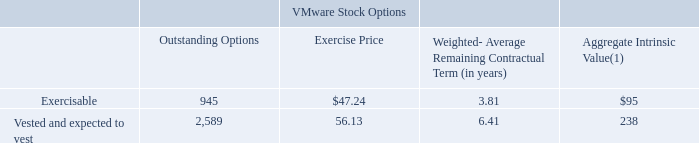Options outstanding that are exercisable and that have vested and are expected to vest as of January 31, 2020 were as follows (outstanding options in thousands, aggregate intrinsic value in in millions):
(1) The aggregate intrinsic values represent the total pre-tax intrinsic values based on VMware's closing stock price of $148.06 as of January 31, 2020, which would have been received by the option holders had all in-the-money options been exercised as of that date.
The total fair value of VMware stock options that vested during the years ended January 31, 2020, February 1, 2019 and February 2, 2018 was $64 million, $35 million and $32 million, respectively. Total fair value of Pivotal stock options that vested during the years ended January 31, 2020, February 1, 2019 and February 2, 2018 was $27 million, $41 million and $23 million, respectively.
The VMware stock options exercised during the years ended January 31, 2020, February 1, 2019 and February 2, 2018 had a pre-tax intrinsic value of $103 million, $56 million, and $62 million, respectively. The Pivotal options exercised during the years ended January 31, 2020 and February 1, 2019 had a pre-tax intrinsic value of $278 million and $97 million, respectively, and was not material during the year ended February 2, 2018. The pre-tax intrinsic value of Pivotal options exercised during the year ended January 31, 2020 includes vested options that were settled in cash as part of the Pivotal acquisition.
What did the aggregate intrinsic value represent? The total pre-tax intrinsic values based on vmware's closing stock price of $148.06 as of january 31, 2020, which would have been received by the option holders had all in-the-money options been exercised as of that date. What was the amount of exercisable outstanding options?
Answer scale should be: thousand. 945. What was the aggregate intrinsic value that was vested and expected to vest?
Answer scale should be: million. 238. What was the difference between outstanding options that were exercisable and vested and expected to vest?
Answer scale should be: thousand. 2,589-945
Answer: 1644. Which types of options had an exercise price that exceeded $50.00? 56.13
Answer: vested and expected to vest. What was the difference between the aggregate intrinsic value between exercisable and vested and expected to vest options? 
Answer scale should be: million. 238-95
Answer: 143. 